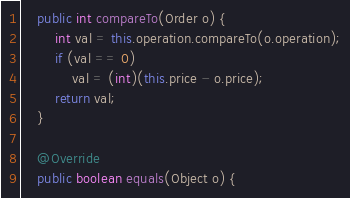<code> <loc_0><loc_0><loc_500><loc_500><_Java_>    public int compareTo(Order o) {
        int val = this.operation.compareTo(o.operation);
        if (val == 0)
            val = (int)(this.price - o.price);
        return val;
    }

    @Override
    public boolean equals(Object o) {</code> 